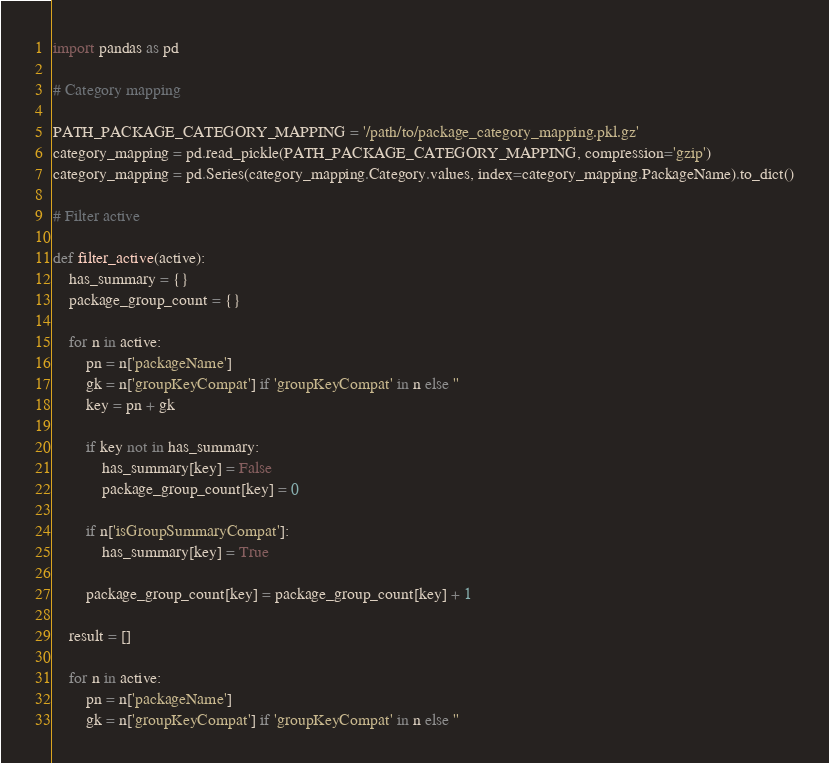<code> <loc_0><loc_0><loc_500><loc_500><_Python_>import pandas as pd

# Category mapping

PATH_PACKAGE_CATEGORY_MAPPING = '/path/to/package_category_mapping.pkl.gz'
category_mapping = pd.read_pickle(PATH_PACKAGE_CATEGORY_MAPPING, compression='gzip')
category_mapping = pd.Series(category_mapping.Category.values, index=category_mapping.PackageName).to_dict()

# Filter active

def filter_active(active):
    has_summary = {}
    package_group_count = {}

    for n in active:
        pn = n['packageName']
        gk = n['groupKeyCompat'] if 'groupKeyCompat' in n else ''
        key = pn + gk

        if key not in has_summary:
            has_summary[key] = False
            package_group_count[key] = 0

        if n['isGroupSummaryCompat']:
            has_summary[key] = True

        package_group_count[key] = package_group_count[key] + 1

    result = []

    for n in active:
        pn = n['packageName']
        gk = n['groupKeyCompat'] if 'groupKeyCompat' in n else ''</code> 